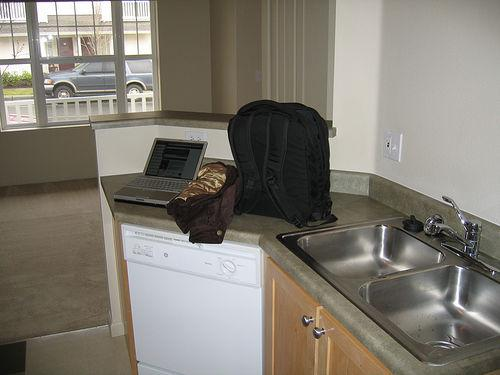Where is someone working? kitchen 